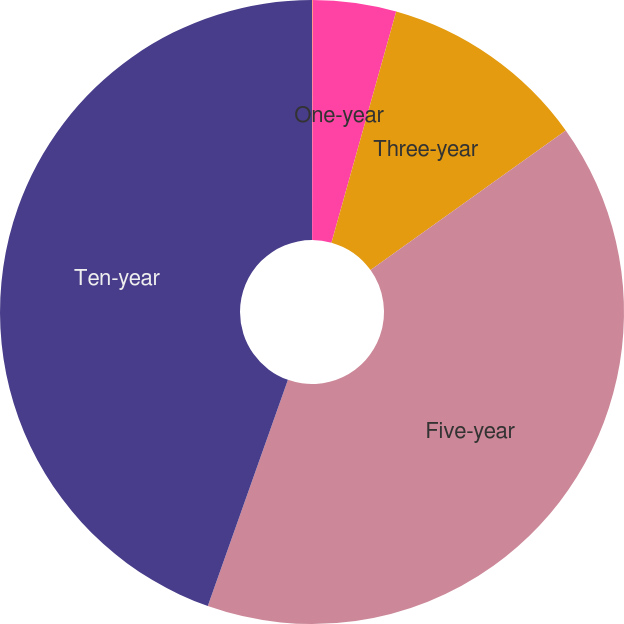Convert chart. <chart><loc_0><loc_0><loc_500><loc_500><pie_chart><fcel>Three-months<fcel>One-year<fcel>Three-year<fcel>Five-year<fcel>Ten-year<nl><fcel>0.03%<fcel>4.32%<fcel>10.77%<fcel>40.3%<fcel>44.58%<nl></chart> 